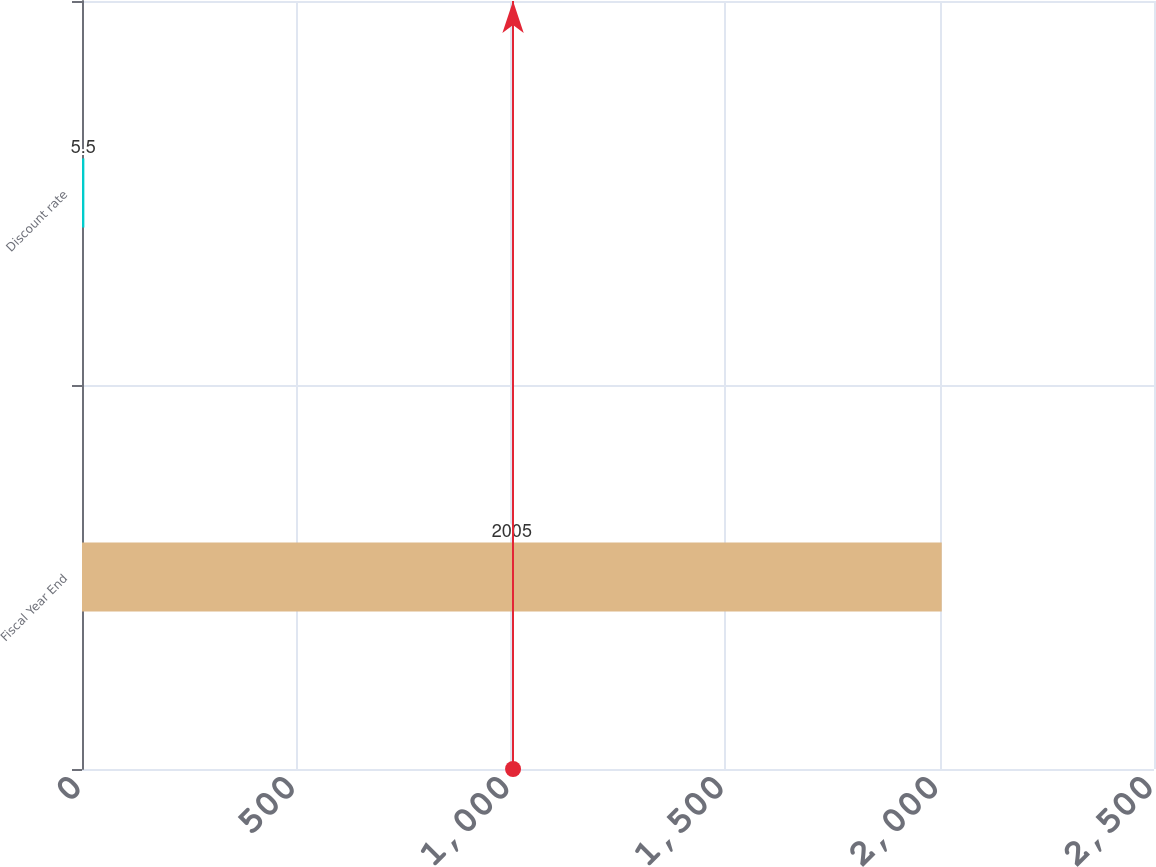<chart> <loc_0><loc_0><loc_500><loc_500><bar_chart><fcel>Fiscal Year End<fcel>Discount rate<nl><fcel>2005<fcel>5.5<nl></chart> 